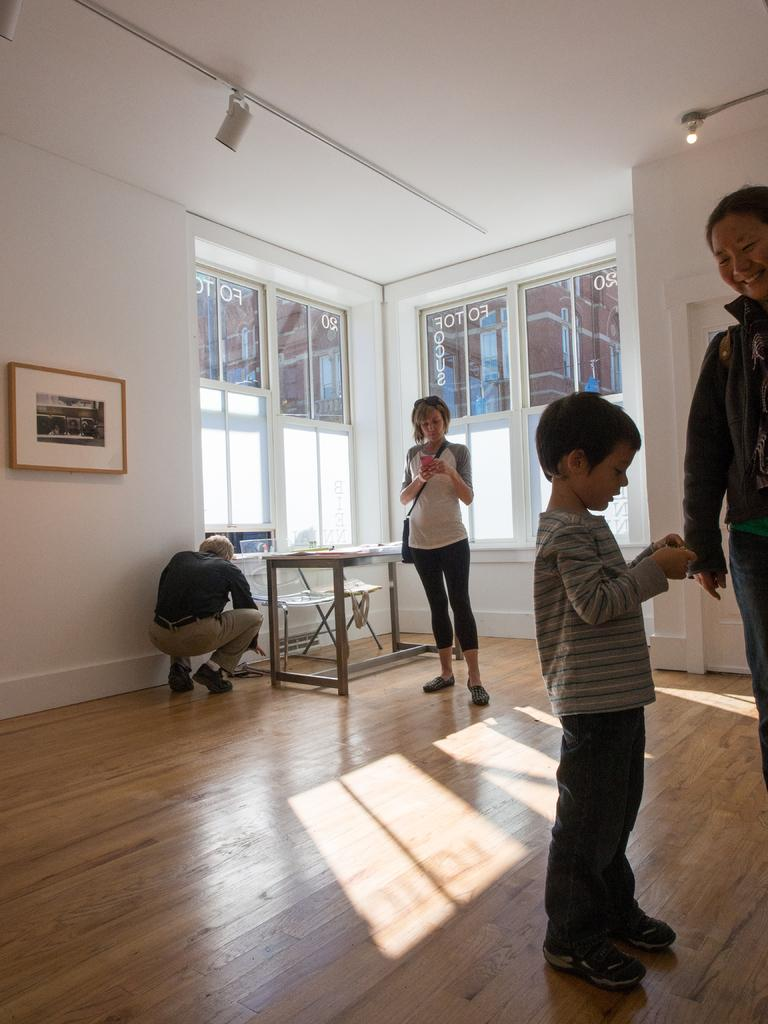How many people are in the room? There are four people in the room. Can you describe the positions of the people in the room? A boy is standing with a woman in front of him, a girl is standing behind the boy, and a man is in a squat position beside a table. What type of faucet is visible in the room? There is no faucet present in the image. How many toes can be seen on the girl's feet in the image? The image does not show the girl's feet, so it is not possible to determine the number of toes visible. 